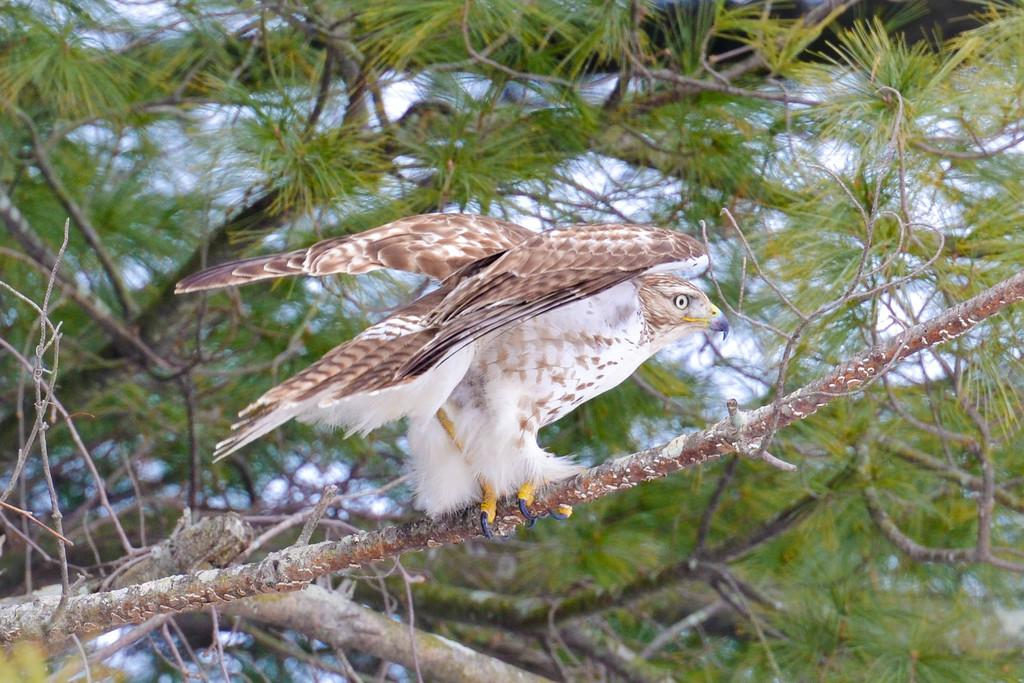What type of animal is present in the image? There is a bird in the image. What is the bird perched on in the image? The bird is perched on branches of a tree in the image. What part of the natural environment is visible in the image? The sky is visible in the image. Where are the pigs playing in the image? There are no pigs present in the image. What type of insect can be seen on the branches of the tree in the image? There is no insect, such as a ladybug, present on the branches of the tree in the image. 